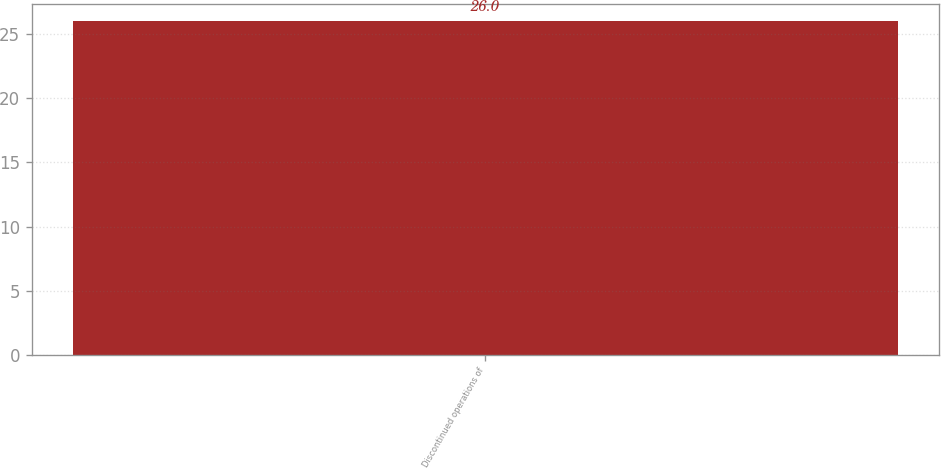<chart> <loc_0><loc_0><loc_500><loc_500><bar_chart><fcel>Discontinued operations of<nl><fcel>26<nl></chart> 